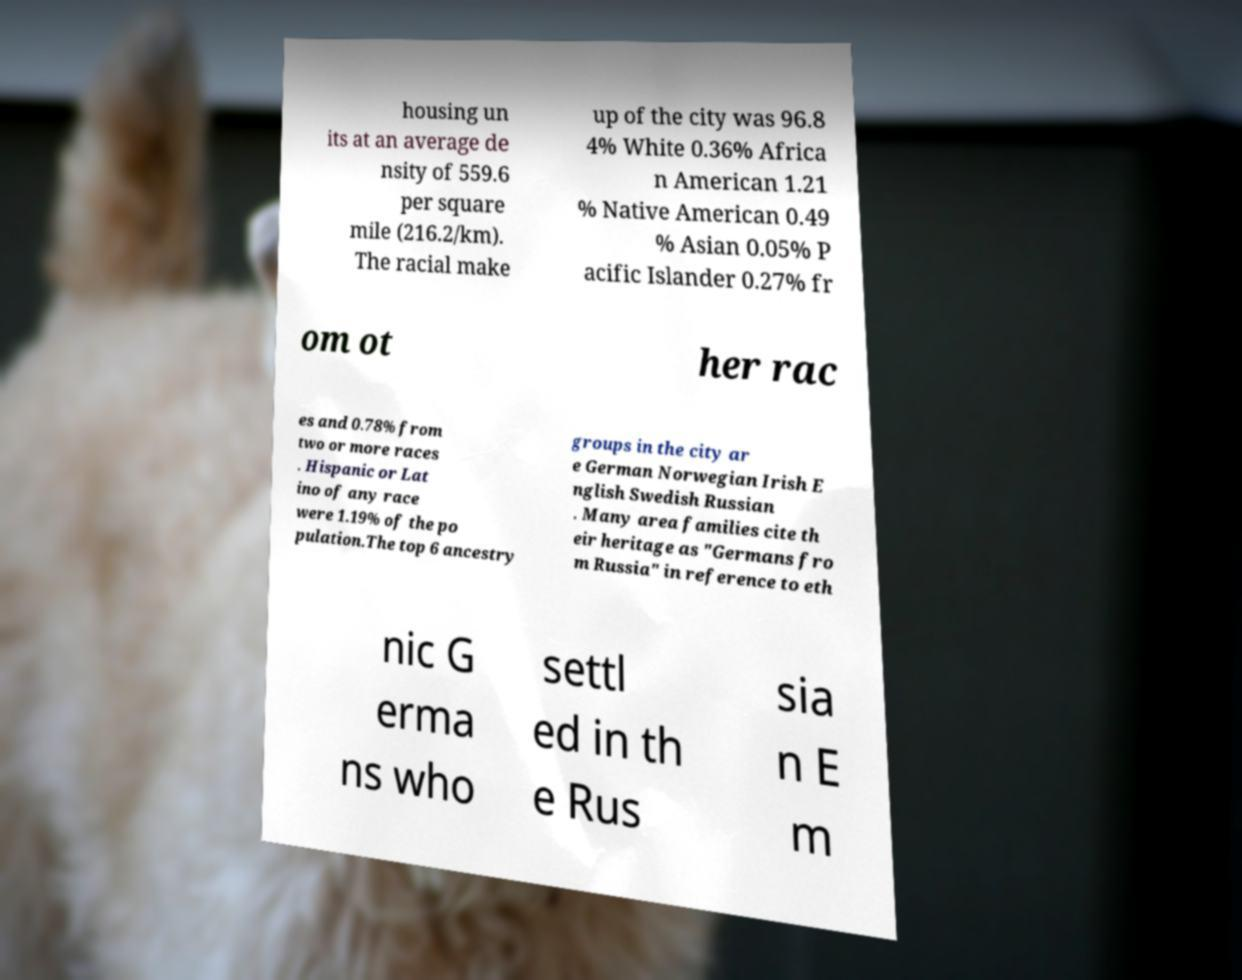Can you accurately transcribe the text from the provided image for me? housing un its at an average de nsity of 559.6 per square mile (216.2/km). The racial make up of the city was 96.8 4% White 0.36% Africa n American 1.21 % Native American 0.49 % Asian 0.05% P acific Islander 0.27% fr om ot her rac es and 0.78% from two or more races . Hispanic or Lat ino of any race were 1.19% of the po pulation.The top 6 ancestry groups in the city ar e German Norwegian Irish E nglish Swedish Russian . Many area families cite th eir heritage as "Germans fro m Russia" in reference to eth nic G erma ns who settl ed in th e Rus sia n E m 